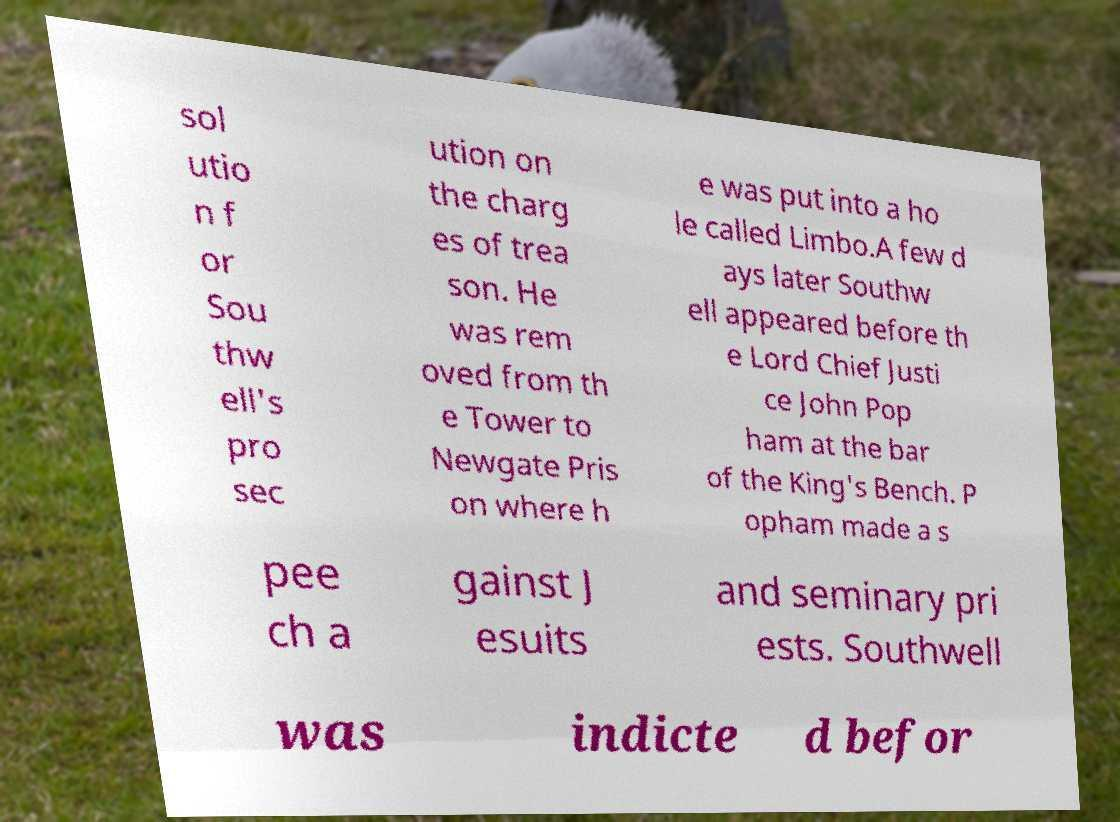Could you extract and type out the text from this image? sol utio n f or Sou thw ell's pro sec ution on the charg es of trea son. He was rem oved from th e Tower to Newgate Pris on where h e was put into a ho le called Limbo.A few d ays later Southw ell appeared before th e Lord Chief Justi ce John Pop ham at the bar of the King's Bench. P opham made a s pee ch a gainst J esuits and seminary pri ests. Southwell was indicte d befor 